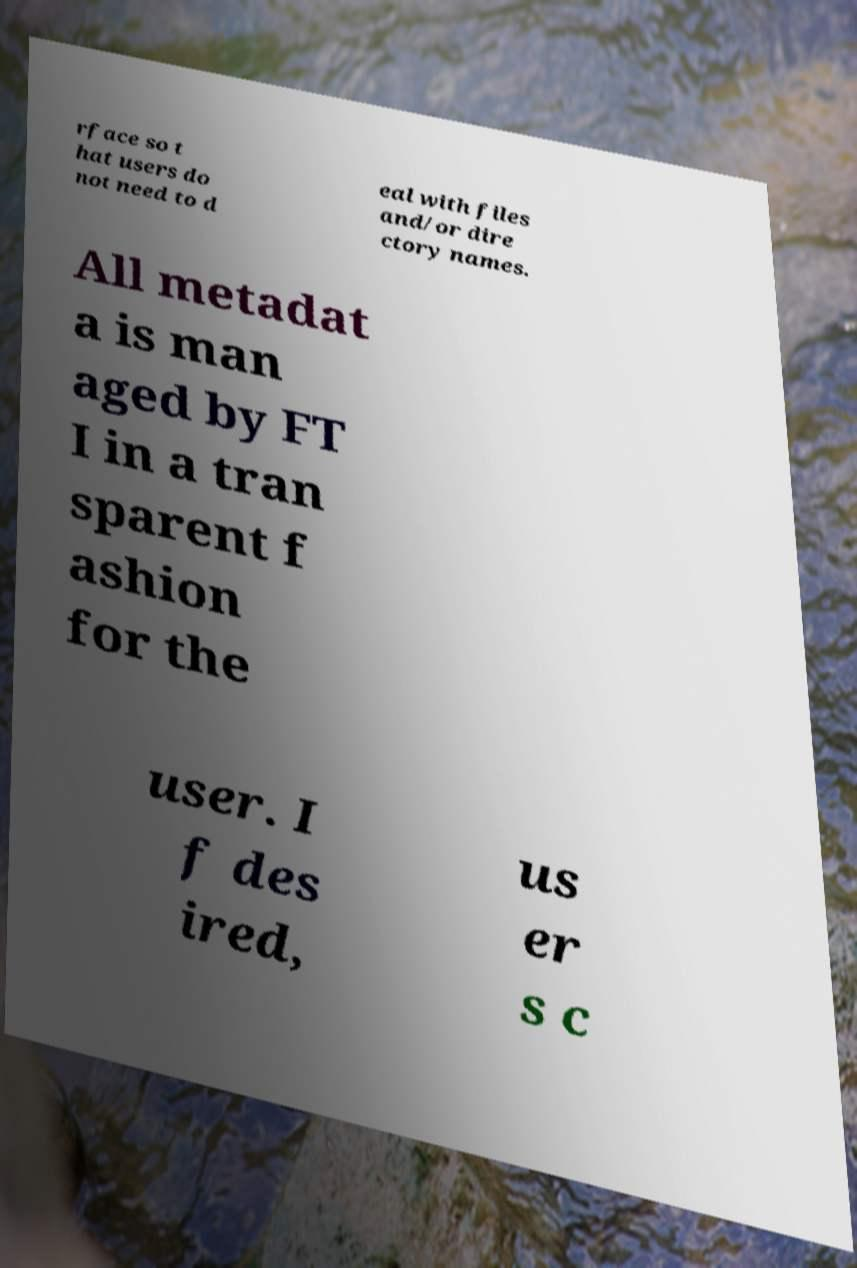Can you read and provide the text displayed in the image?This photo seems to have some interesting text. Can you extract and type it out for me? rface so t hat users do not need to d eal with files and/or dire ctory names. All metadat a is man aged by FT I in a tran sparent f ashion for the user. I f des ired, us er s c 